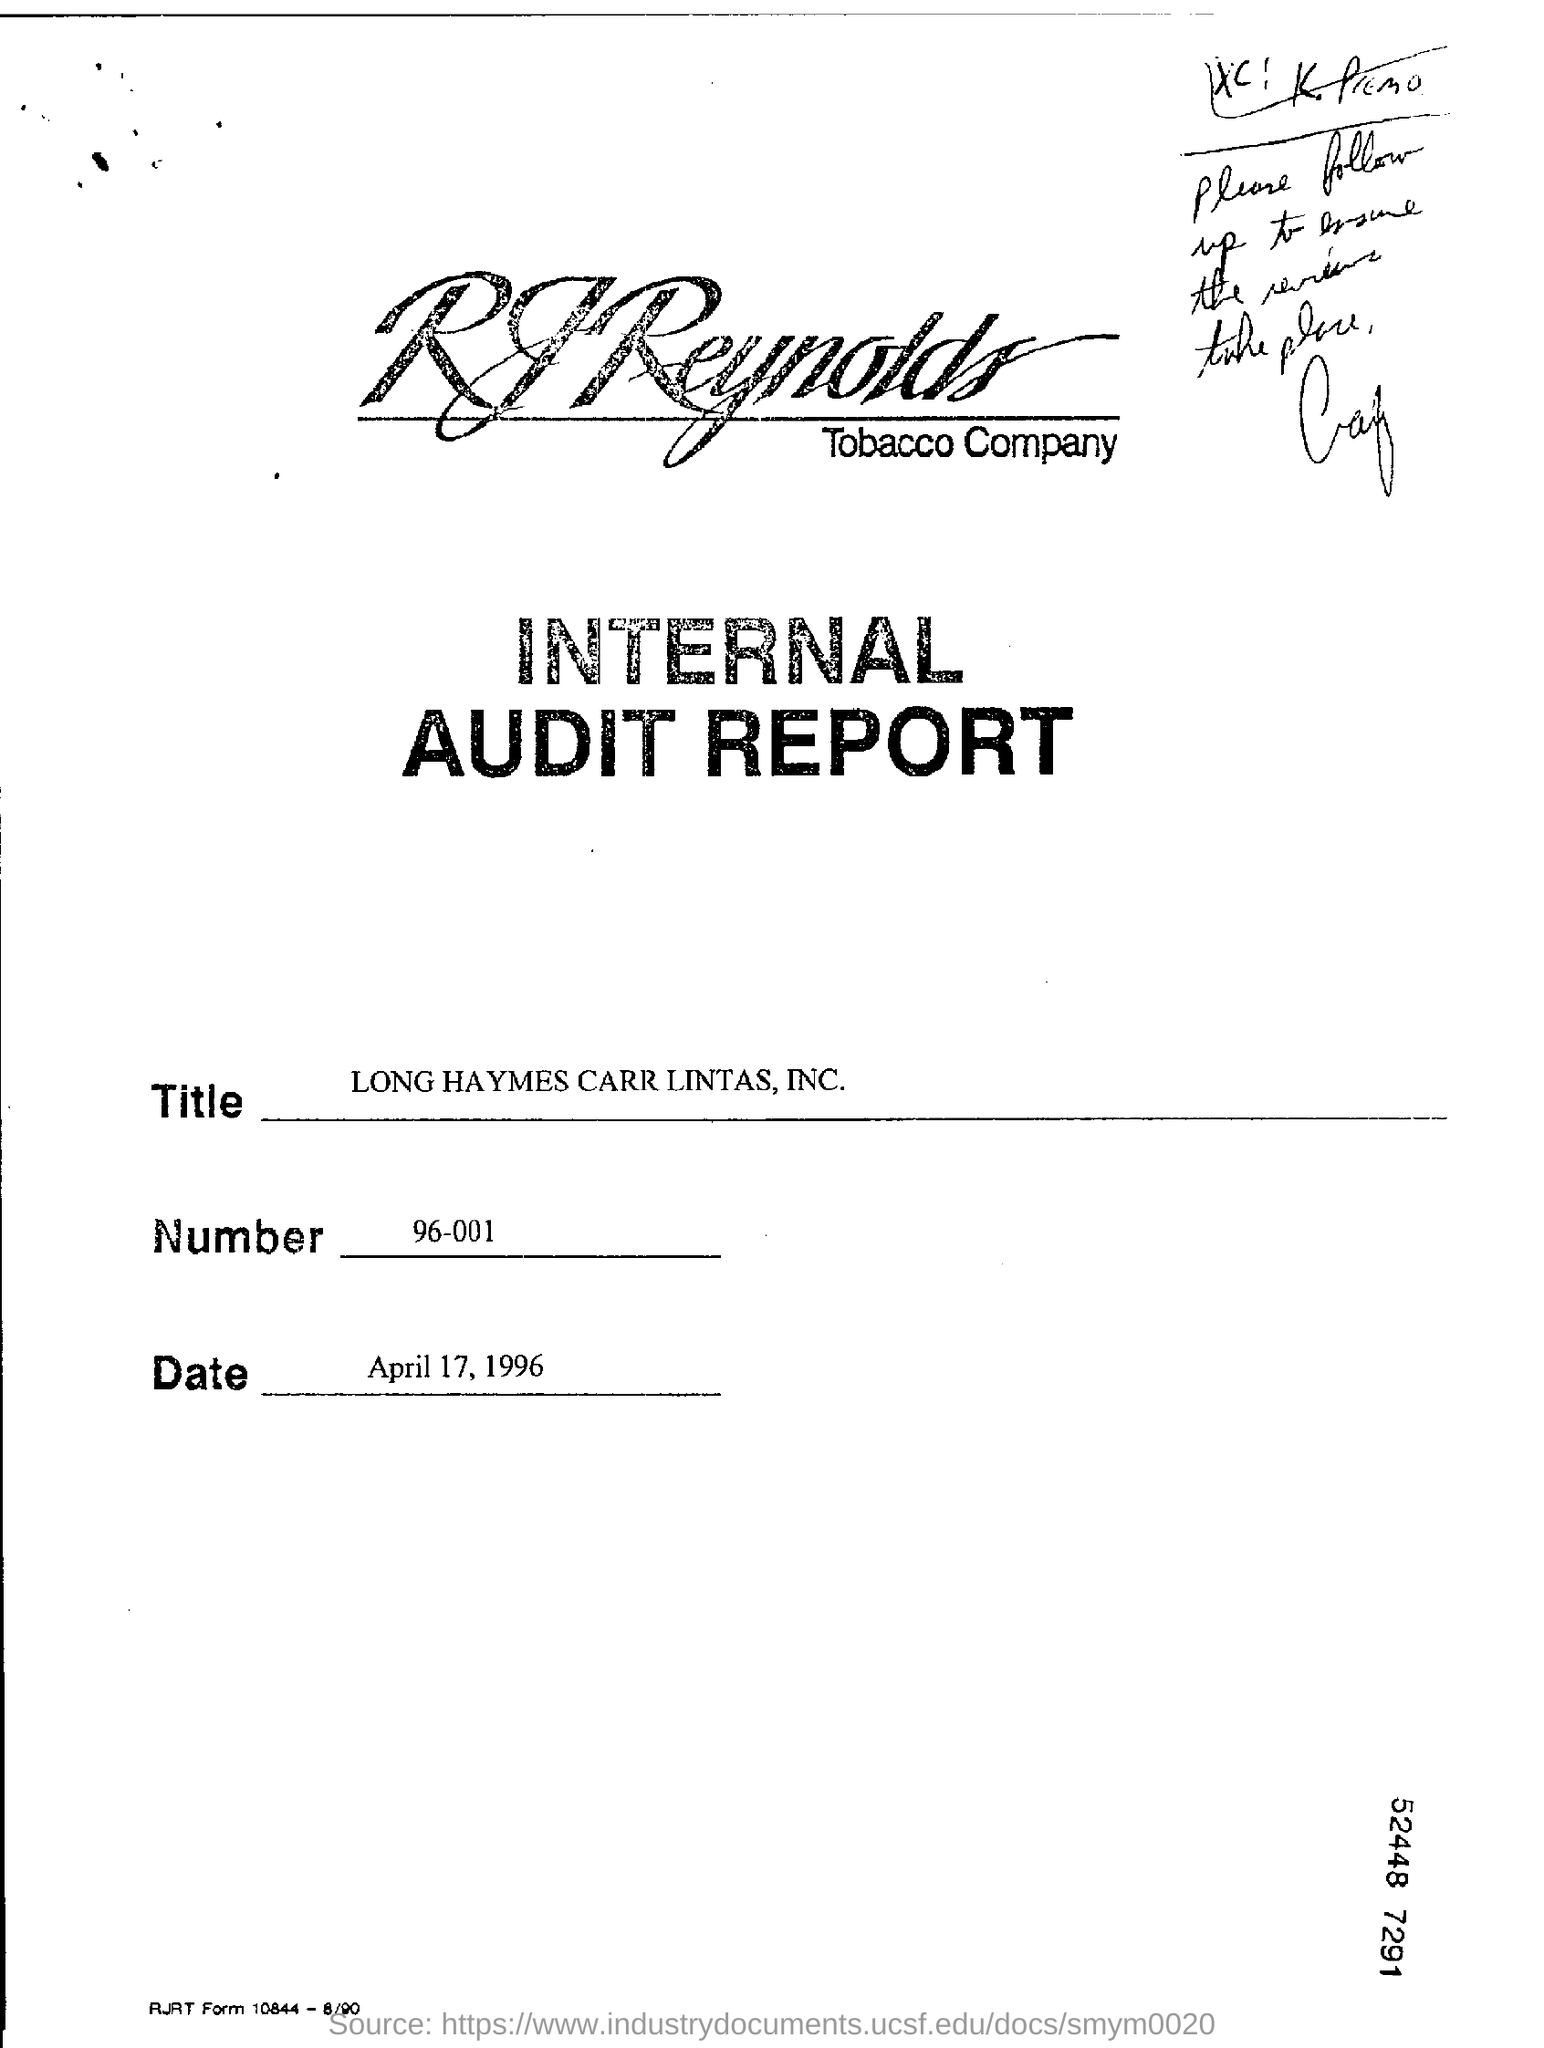Which Company's Audit Report is given here?
Keep it short and to the point. RJReynolds Tobacco Company. What is the date mentioned in this document?
Keep it short and to the point. April 17 , 1996. What is the Number mentioned in the document?
Offer a very short reply. 96-001. What is the title mentioned in this document?
Give a very brief answer. LONG HAYMES CARR LINTAS, INC. 